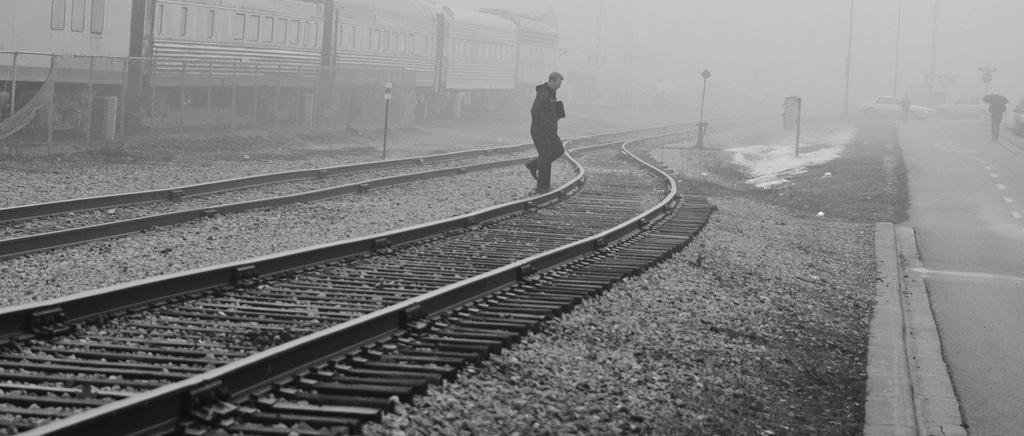How would you summarize this image in a sentence or two? This image is a black and white image. This image is taken outdoors. At the bottom of the image there are many pebbles on the ground and there is a railway track. In the background there is a train on the track. In the middle of the image there are two railway tracks. A man is walking. There is a pole. On the right side of the image there is a road. A few vehicles are moving on the road and there are few poles. 